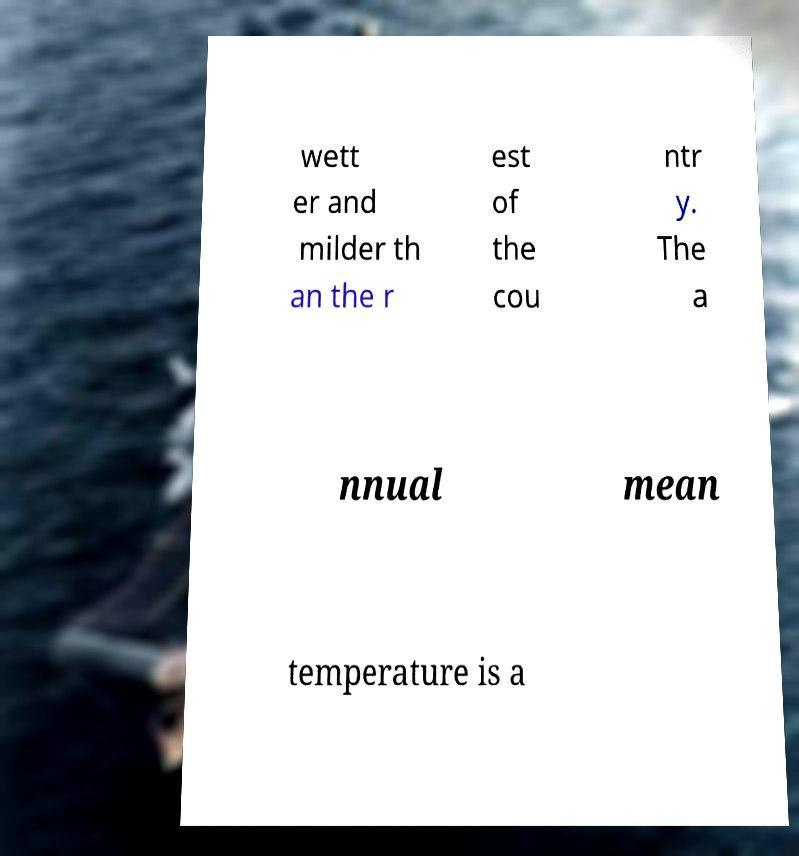What messages or text are displayed in this image? I need them in a readable, typed format. wett er and milder th an the r est of the cou ntr y. The a nnual mean temperature is a 